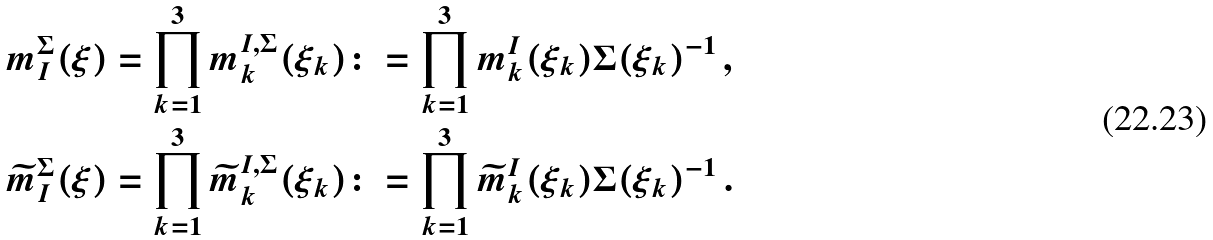<formula> <loc_0><loc_0><loc_500><loc_500>m _ { I } ^ { \Sigma } ( \xi ) & = \prod _ { k = 1 } ^ { 3 } m _ { k } ^ { I , \Sigma } ( \xi _ { k } ) \colon = \prod _ { k = 1 } ^ { 3 } m _ { k } ^ { I } ( \xi _ { k } ) \Sigma ( \xi _ { k } ) ^ { - 1 } \, , \\ \widetilde { m } _ { I } ^ { \Sigma } ( \xi ) & = \prod _ { k = 1 } ^ { 3 } \widetilde { m } _ { k } ^ { I , \Sigma } ( \xi _ { k } ) \colon = \prod _ { k = 1 } ^ { 3 } \widetilde { m } _ { k } ^ { I } ( \xi _ { k } ) \Sigma ( \xi _ { k } ) ^ { - 1 } \, .</formula> 